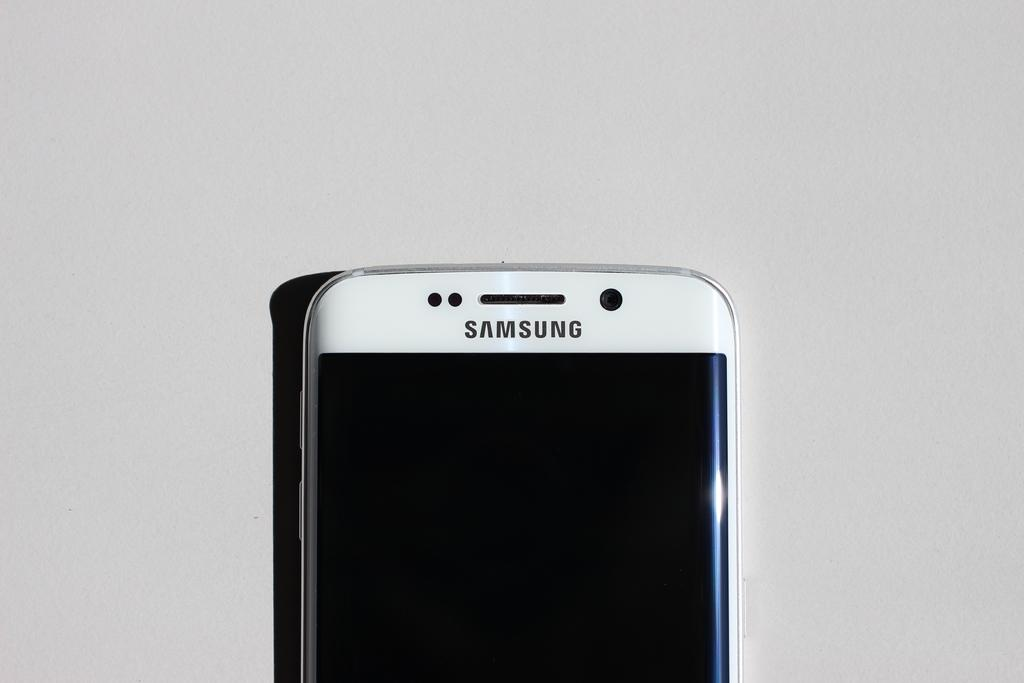<image>
Describe the image concisely. A Samsung cell phone with a strip of white on the top. 